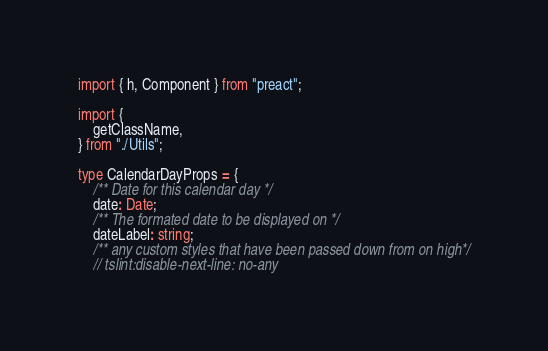Convert code to text. <code><loc_0><loc_0><loc_500><loc_500><_TypeScript_>import { h, Component } from "preact";

import {
    getClassName,
} from "./Utils";

type CalendarDayProps = {
    /** Date for this calendar day */
    date: Date;
    /** The formated date to be displayed on */
    dateLabel: string;
    /** any custom styles that have been passed down from on high*/
    // tslint:disable-next-line: no-any</code> 